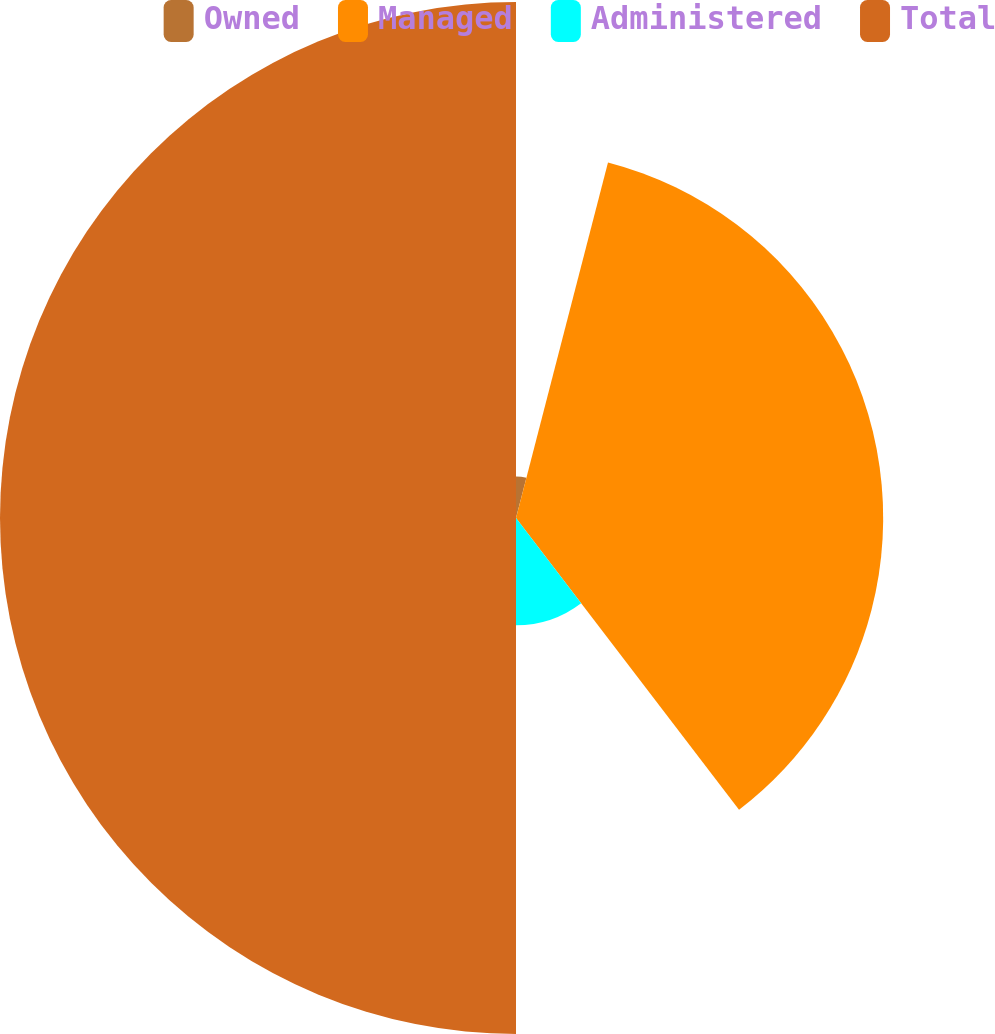Convert chart. <chart><loc_0><loc_0><loc_500><loc_500><pie_chart><fcel>Owned<fcel>Managed<fcel>Administered<fcel>Total<nl><fcel>4.03%<fcel>35.58%<fcel>10.39%<fcel>50.0%<nl></chart> 